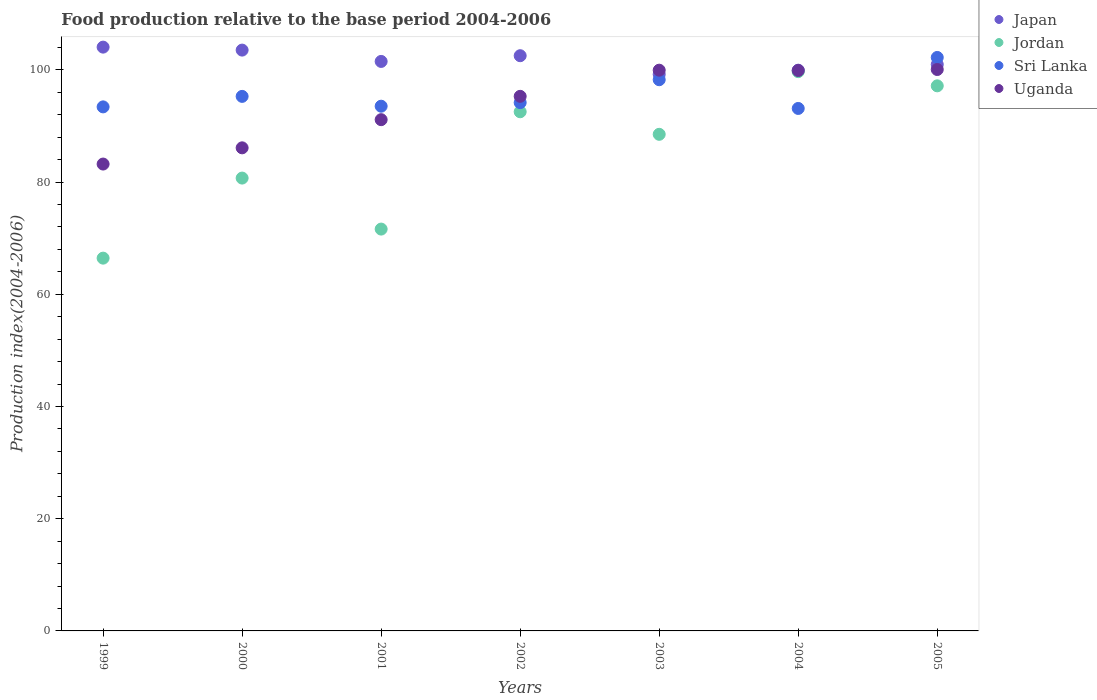How many different coloured dotlines are there?
Your answer should be very brief. 4. What is the food production index in Sri Lanka in 2005?
Your response must be concise. 102.21. Across all years, what is the maximum food production index in Jordan?
Provide a succinct answer. 99.68. Across all years, what is the minimum food production index in Jordan?
Provide a short and direct response. 66.44. What is the total food production index in Uganda in the graph?
Make the answer very short. 655.59. What is the difference between the food production index in Jordan in 1999 and that in 2001?
Your answer should be compact. -5.18. What is the difference between the food production index in Japan in 2002 and the food production index in Uganda in 1999?
Give a very brief answer. 19.31. What is the average food production index in Uganda per year?
Give a very brief answer. 93.66. In the year 2001, what is the difference between the food production index in Jordan and food production index in Uganda?
Give a very brief answer. -19.5. What is the ratio of the food production index in Jordan in 2000 to that in 2004?
Your answer should be very brief. 0.81. Is the food production index in Japan in 2004 less than that in 2005?
Your answer should be compact. Yes. Is the difference between the food production index in Jordan in 1999 and 2005 greater than the difference between the food production index in Uganda in 1999 and 2005?
Ensure brevity in your answer.  No. What is the difference between the highest and the second highest food production index in Sri Lanka?
Provide a short and direct response. 3.97. What is the difference between the highest and the lowest food production index in Sri Lanka?
Make the answer very short. 9.09. Is the sum of the food production index in Japan in 1999 and 2003 greater than the maximum food production index in Sri Lanka across all years?
Offer a terse response. Yes. Does the food production index in Jordan monotonically increase over the years?
Keep it short and to the point. No. Is the food production index in Jordan strictly less than the food production index in Uganda over the years?
Offer a very short reply. Yes. What is the difference between two consecutive major ticks on the Y-axis?
Your response must be concise. 20. Does the graph contain any zero values?
Your response must be concise. No. Does the graph contain grids?
Make the answer very short. No. Where does the legend appear in the graph?
Keep it short and to the point. Top right. How many legend labels are there?
Your response must be concise. 4. How are the legend labels stacked?
Keep it short and to the point. Vertical. What is the title of the graph?
Keep it short and to the point. Food production relative to the base period 2004-2006. What is the label or title of the Y-axis?
Keep it short and to the point. Production index(2004-2006). What is the Production index(2004-2006) in Japan in 1999?
Give a very brief answer. 104.05. What is the Production index(2004-2006) in Jordan in 1999?
Give a very brief answer. 66.44. What is the Production index(2004-2006) of Sri Lanka in 1999?
Your answer should be compact. 93.4. What is the Production index(2004-2006) of Uganda in 1999?
Your answer should be compact. 83.21. What is the Production index(2004-2006) of Japan in 2000?
Offer a very short reply. 103.52. What is the Production index(2004-2006) in Jordan in 2000?
Give a very brief answer. 80.71. What is the Production index(2004-2006) in Sri Lanka in 2000?
Your answer should be very brief. 95.27. What is the Production index(2004-2006) of Uganda in 2000?
Provide a short and direct response. 86.1. What is the Production index(2004-2006) in Japan in 2001?
Ensure brevity in your answer.  101.5. What is the Production index(2004-2006) in Jordan in 2001?
Make the answer very short. 71.62. What is the Production index(2004-2006) of Sri Lanka in 2001?
Give a very brief answer. 93.52. What is the Production index(2004-2006) in Uganda in 2001?
Give a very brief answer. 91.12. What is the Production index(2004-2006) in Japan in 2002?
Offer a very short reply. 102.52. What is the Production index(2004-2006) of Jordan in 2002?
Your answer should be compact. 92.53. What is the Production index(2004-2006) in Sri Lanka in 2002?
Your answer should be very brief. 94.16. What is the Production index(2004-2006) in Uganda in 2002?
Provide a short and direct response. 95.28. What is the Production index(2004-2006) in Japan in 2003?
Give a very brief answer. 99.2. What is the Production index(2004-2006) in Jordan in 2003?
Your answer should be compact. 88.51. What is the Production index(2004-2006) in Sri Lanka in 2003?
Ensure brevity in your answer.  98.24. What is the Production index(2004-2006) of Uganda in 2003?
Ensure brevity in your answer.  99.94. What is the Production index(2004-2006) of Japan in 2004?
Make the answer very short. 99.94. What is the Production index(2004-2006) of Jordan in 2004?
Ensure brevity in your answer.  99.68. What is the Production index(2004-2006) of Sri Lanka in 2004?
Provide a succinct answer. 93.12. What is the Production index(2004-2006) in Uganda in 2004?
Offer a terse response. 99.88. What is the Production index(2004-2006) of Japan in 2005?
Your response must be concise. 100.96. What is the Production index(2004-2006) of Jordan in 2005?
Keep it short and to the point. 97.15. What is the Production index(2004-2006) of Sri Lanka in 2005?
Your answer should be very brief. 102.21. What is the Production index(2004-2006) of Uganda in 2005?
Make the answer very short. 100.06. Across all years, what is the maximum Production index(2004-2006) of Japan?
Ensure brevity in your answer.  104.05. Across all years, what is the maximum Production index(2004-2006) of Jordan?
Offer a terse response. 99.68. Across all years, what is the maximum Production index(2004-2006) in Sri Lanka?
Provide a short and direct response. 102.21. Across all years, what is the maximum Production index(2004-2006) in Uganda?
Your answer should be compact. 100.06. Across all years, what is the minimum Production index(2004-2006) in Japan?
Your answer should be compact. 99.2. Across all years, what is the minimum Production index(2004-2006) in Jordan?
Give a very brief answer. 66.44. Across all years, what is the minimum Production index(2004-2006) in Sri Lanka?
Keep it short and to the point. 93.12. Across all years, what is the minimum Production index(2004-2006) in Uganda?
Your response must be concise. 83.21. What is the total Production index(2004-2006) in Japan in the graph?
Offer a terse response. 711.69. What is the total Production index(2004-2006) of Jordan in the graph?
Make the answer very short. 596.64. What is the total Production index(2004-2006) in Sri Lanka in the graph?
Give a very brief answer. 669.92. What is the total Production index(2004-2006) in Uganda in the graph?
Offer a very short reply. 655.59. What is the difference between the Production index(2004-2006) in Japan in 1999 and that in 2000?
Your answer should be very brief. 0.53. What is the difference between the Production index(2004-2006) in Jordan in 1999 and that in 2000?
Ensure brevity in your answer.  -14.27. What is the difference between the Production index(2004-2006) in Sri Lanka in 1999 and that in 2000?
Ensure brevity in your answer.  -1.87. What is the difference between the Production index(2004-2006) in Uganda in 1999 and that in 2000?
Your answer should be compact. -2.89. What is the difference between the Production index(2004-2006) in Japan in 1999 and that in 2001?
Keep it short and to the point. 2.55. What is the difference between the Production index(2004-2006) in Jordan in 1999 and that in 2001?
Your answer should be very brief. -5.18. What is the difference between the Production index(2004-2006) in Sri Lanka in 1999 and that in 2001?
Offer a terse response. -0.12. What is the difference between the Production index(2004-2006) in Uganda in 1999 and that in 2001?
Ensure brevity in your answer.  -7.91. What is the difference between the Production index(2004-2006) of Japan in 1999 and that in 2002?
Offer a very short reply. 1.53. What is the difference between the Production index(2004-2006) of Jordan in 1999 and that in 2002?
Give a very brief answer. -26.09. What is the difference between the Production index(2004-2006) in Sri Lanka in 1999 and that in 2002?
Provide a succinct answer. -0.76. What is the difference between the Production index(2004-2006) in Uganda in 1999 and that in 2002?
Offer a very short reply. -12.07. What is the difference between the Production index(2004-2006) in Japan in 1999 and that in 2003?
Provide a short and direct response. 4.85. What is the difference between the Production index(2004-2006) of Jordan in 1999 and that in 2003?
Provide a succinct answer. -22.07. What is the difference between the Production index(2004-2006) in Sri Lanka in 1999 and that in 2003?
Give a very brief answer. -4.84. What is the difference between the Production index(2004-2006) of Uganda in 1999 and that in 2003?
Keep it short and to the point. -16.73. What is the difference between the Production index(2004-2006) in Japan in 1999 and that in 2004?
Your answer should be very brief. 4.11. What is the difference between the Production index(2004-2006) of Jordan in 1999 and that in 2004?
Provide a succinct answer. -33.24. What is the difference between the Production index(2004-2006) in Sri Lanka in 1999 and that in 2004?
Provide a short and direct response. 0.28. What is the difference between the Production index(2004-2006) in Uganda in 1999 and that in 2004?
Offer a terse response. -16.67. What is the difference between the Production index(2004-2006) in Japan in 1999 and that in 2005?
Ensure brevity in your answer.  3.09. What is the difference between the Production index(2004-2006) of Jordan in 1999 and that in 2005?
Offer a terse response. -30.71. What is the difference between the Production index(2004-2006) in Sri Lanka in 1999 and that in 2005?
Your answer should be very brief. -8.81. What is the difference between the Production index(2004-2006) of Uganda in 1999 and that in 2005?
Offer a terse response. -16.85. What is the difference between the Production index(2004-2006) in Japan in 2000 and that in 2001?
Provide a short and direct response. 2.02. What is the difference between the Production index(2004-2006) of Jordan in 2000 and that in 2001?
Your answer should be very brief. 9.09. What is the difference between the Production index(2004-2006) of Uganda in 2000 and that in 2001?
Provide a succinct answer. -5.02. What is the difference between the Production index(2004-2006) of Jordan in 2000 and that in 2002?
Your answer should be very brief. -11.82. What is the difference between the Production index(2004-2006) of Sri Lanka in 2000 and that in 2002?
Keep it short and to the point. 1.11. What is the difference between the Production index(2004-2006) in Uganda in 2000 and that in 2002?
Provide a short and direct response. -9.18. What is the difference between the Production index(2004-2006) of Japan in 2000 and that in 2003?
Keep it short and to the point. 4.32. What is the difference between the Production index(2004-2006) of Sri Lanka in 2000 and that in 2003?
Keep it short and to the point. -2.97. What is the difference between the Production index(2004-2006) of Uganda in 2000 and that in 2003?
Keep it short and to the point. -13.84. What is the difference between the Production index(2004-2006) of Japan in 2000 and that in 2004?
Provide a succinct answer. 3.58. What is the difference between the Production index(2004-2006) of Jordan in 2000 and that in 2004?
Offer a terse response. -18.97. What is the difference between the Production index(2004-2006) of Sri Lanka in 2000 and that in 2004?
Ensure brevity in your answer.  2.15. What is the difference between the Production index(2004-2006) in Uganda in 2000 and that in 2004?
Ensure brevity in your answer.  -13.78. What is the difference between the Production index(2004-2006) in Japan in 2000 and that in 2005?
Give a very brief answer. 2.56. What is the difference between the Production index(2004-2006) of Jordan in 2000 and that in 2005?
Provide a short and direct response. -16.44. What is the difference between the Production index(2004-2006) in Sri Lanka in 2000 and that in 2005?
Offer a very short reply. -6.94. What is the difference between the Production index(2004-2006) in Uganda in 2000 and that in 2005?
Offer a very short reply. -13.96. What is the difference between the Production index(2004-2006) of Japan in 2001 and that in 2002?
Your response must be concise. -1.02. What is the difference between the Production index(2004-2006) in Jordan in 2001 and that in 2002?
Your response must be concise. -20.91. What is the difference between the Production index(2004-2006) in Sri Lanka in 2001 and that in 2002?
Your response must be concise. -0.64. What is the difference between the Production index(2004-2006) in Uganda in 2001 and that in 2002?
Offer a terse response. -4.16. What is the difference between the Production index(2004-2006) of Jordan in 2001 and that in 2003?
Offer a very short reply. -16.89. What is the difference between the Production index(2004-2006) of Sri Lanka in 2001 and that in 2003?
Your answer should be compact. -4.72. What is the difference between the Production index(2004-2006) of Uganda in 2001 and that in 2003?
Give a very brief answer. -8.82. What is the difference between the Production index(2004-2006) of Japan in 2001 and that in 2004?
Keep it short and to the point. 1.56. What is the difference between the Production index(2004-2006) in Jordan in 2001 and that in 2004?
Give a very brief answer. -28.06. What is the difference between the Production index(2004-2006) of Uganda in 2001 and that in 2004?
Keep it short and to the point. -8.76. What is the difference between the Production index(2004-2006) in Japan in 2001 and that in 2005?
Provide a short and direct response. 0.54. What is the difference between the Production index(2004-2006) of Jordan in 2001 and that in 2005?
Offer a very short reply. -25.53. What is the difference between the Production index(2004-2006) of Sri Lanka in 2001 and that in 2005?
Your response must be concise. -8.69. What is the difference between the Production index(2004-2006) of Uganda in 2001 and that in 2005?
Provide a succinct answer. -8.94. What is the difference between the Production index(2004-2006) in Japan in 2002 and that in 2003?
Provide a succinct answer. 3.32. What is the difference between the Production index(2004-2006) in Jordan in 2002 and that in 2003?
Provide a succinct answer. 4.02. What is the difference between the Production index(2004-2006) of Sri Lanka in 2002 and that in 2003?
Provide a short and direct response. -4.08. What is the difference between the Production index(2004-2006) in Uganda in 2002 and that in 2003?
Keep it short and to the point. -4.66. What is the difference between the Production index(2004-2006) in Japan in 2002 and that in 2004?
Keep it short and to the point. 2.58. What is the difference between the Production index(2004-2006) of Jordan in 2002 and that in 2004?
Ensure brevity in your answer.  -7.15. What is the difference between the Production index(2004-2006) in Uganda in 2002 and that in 2004?
Provide a succinct answer. -4.6. What is the difference between the Production index(2004-2006) of Japan in 2002 and that in 2005?
Make the answer very short. 1.56. What is the difference between the Production index(2004-2006) in Jordan in 2002 and that in 2005?
Provide a succinct answer. -4.62. What is the difference between the Production index(2004-2006) in Sri Lanka in 2002 and that in 2005?
Offer a terse response. -8.05. What is the difference between the Production index(2004-2006) of Uganda in 2002 and that in 2005?
Offer a terse response. -4.78. What is the difference between the Production index(2004-2006) of Japan in 2003 and that in 2004?
Offer a very short reply. -0.74. What is the difference between the Production index(2004-2006) in Jordan in 2003 and that in 2004?
Give a very brief answer. -11.17. What is the difference between the Production index(2004-2006) in Sri Lanka in 2003 and that in 2004?
Offer a terse response. 5.12. What is the difference between the Production index(2004-2006) in Japan in 2003 and that in 2005?
Ensure brevity in your answer.  -1.76. What is the difference between the Production index(2004-2006) in Jordan in 2003 and that in 2005?
Provide a short and direct response. -8.64. What is the difference between the Production index(2004-2006) in Sri Lanka in 2003 and that in 2005?
Ensure brevity in your answer.  -3.97. What is the difference between the Production index(2004-2006) of Uganda in 2003 and that in 2005?
Provide a short and direct response. -0.12. What is the difference between the Production index(2004-2006) of Japan in 2004 and that in 2005?
Ensure brevity in your answer.  -1.02. What is the difference between the Production index(2004-2006) in Jordan in 2004 and that in 2005?
Provide a short and direct response. 2.53. What is the difference between the Production index(2004-2006) of Sri Lanka in 2004 and that in 2005?
Provide a short and direct response. -9.09. What is the difference between the Production index(2004-2006) in Uganda in 2004 and that in 2005?
Offer a terse response. -0.18. What is the difference between the Production index(2004-2006) in Japan in 1999 and the Production index(2004-2006) in Jordan in 2000?
Make the answer very short. 23.34. What is the difference between the Production index(2004-2006) of Japan in 1999 and the Production index(2004-2006) of Sri Lanka in 2000?
Your answer should be compact. 8.78. What is the difference between the Production index(2004-2006) in Japan in 1999 and the Production index(2004-2006) in Uganda in 2000?
Keep it short and to the point. 17.95. What is the difference between the Production index(2004-2006) of Jordan in 1999 and the Production index(2004-2006) of Sri Lanka in 2000?
Give a very brief answer. -28.83. What is the difference between the Production index(2004-2006) in Jordan in 1999 and the Production index(2004-2006) in Uganda in 2000?
Provide a short and direct response. -19.66. What is the difference between the Production index(2004-2006) in Japan in 1999 and the Production index(2004-2006) in Jordan in 2001?
Ensure brevity in your answer.  32.43. What is the difference between the Production index(2004-2006) of Japan in 1999 and the Production index(2004-2006) of Sri Lanka in 2001?
Make the answer very short. 10.53. What is the difference between the Production index(2004-2006) in Japan in 1999 and the Production index(2004-2006) in Uganda in 2001?
Provide a succinct answer. 12.93. What is the difference between the Production index(2004-2006) in Jordan in 1999 and the Production index(2004-2006) in Sri Lanka in 2001?
Give a very brief answer. -27.08. What is the difference between the Production index(2004-2006) in Jordan in 1999 and the Production index(2004-2006) in Uganda in 2001?
Provide a succinct answer. -24.68. What is the difference between the Production index(2004-2006) of Sri Lanka in 1999 and the Production index(2004-2006) of Uganda in 2001?
Your answer should be very brief. 2.28. What is the difference between the Production index(2004-2006) in Japan in 1999 and the Production index(2004-2006) in Jordan in 2002?
Your response must be concise. 11.52. What is the difference between the Production index(2004-2006) in Japan in 1999 and the Production index(2004-2006) in Sri Lanka in 2002?
Make the answer very short. 9.89. What is the difference between the Production index(2004-2006) of Japan in 1999 and the Production index(2004-2006) of Uganda in 2002?
Keep it short and to the point. 8.77. What is the difference between the Production index(2004-2006) of Jordan in 1999 and the Production index(2004-2006) of Sri Lanka in 2002?
Your answer should be very brief. -27.72. What is the difference between the Production index(2004-2006) in Jordan in 1999 and the Production index(2004-2006) in Uganda in 2002?
Keep it short and to the point. -28.84. What is the difference between the Production index(2004-2006) of Sri Lanka in 1999 and the Production index(2004-2006) of Uganda in 2002?
Keep it short and to the point. -1.88. What is the difference between the Production index(2004-2006) of Japan in 1999 and the Production index(2004-2006) of Jordan in 2003?
Provide a succinct answer. 15.54. What is the difference between the Production index(2004-2006) in Japan in 1999 and the Production index(2004-2006) in Sri Lanka in 2003?
Make the answer very short. 5.81. What is the difference between the Production index(2004-2006) in Japan in 1999 and the Production index(2004-2006) in Uganda in 2003?
Offer a very short reply. 4.11. What is the difference between the Production index(2004-2006) of Jordan in 1999 and the Production index(2004-2006) of Sri Lanka in 2003?
Your response must be concise. -31.8. What is the difference between the Production index(2004-2006) in Jordan in 1999 and the Production index(2004-2006) in Uganda in 2003?
Make the answer very short. -33.5. What is the difference between the Production index(2004-2006) of Sri Lanka in 1999 and the Production index(2004-2006) of Uganda in 2003?
Offer a terse response. -6.54. What is the difference between the Production index(2004-2006) of Japan in 1999 and the Production index(2004-2006) of Jordan in 2004?
Make the answer very short. 4.37. What is the difference between the Production index(2004-2006) in Japan in 1999 and the Production index(2004-2006) in Sri Lanka in 2004?
Make the answer very short. 10.93. What is the difference between the Production index(2004-2006) in Japan in 1999 and the Production index(2004-2006) in Uganda in 2004?
Your response must be concise. 4.17. What is the difference between the Production index(2004-2006) of Jordan in 1999 and the Production index(2004-2006) of Sri Lanka in 2004?
Provide a short and direct response. -26.68. What is the difference between the Production index(2004-2006) in Jordan in 1999 and the Production index(2004-2006) in Uganda in 2004?
Make the answer very short. -33.44. What is the difference between the Production index(2004-2006) in Sri Lanka in 1999 and the Production index(2004-2006) in Uganda in 2004?
Provide a short and direct response. -6.48. What is the difference between the Production index(2004-2006) of Japan in 1999 and the Production index(2004-2006) of Sri Lanka in 2005?
Your answer should be compact. 1.84. What is the difference between the Production index(2004-2006) of Japan in 1999 and the Production index(2004-2006) of Uganda in 2005?
Make the answer very short. 3.99. What is the difference between the Production index(2004-2006) in Jordan in 1999 and the Production index(2004-2006) in Sri Lanka in 2005?
Ensure brevity in your answer.  -35.77. What is the difference between the Production index(2004-2006) in Jordan in 1999 and the Production index(2004-2006) in Uganda in 2005?
Make the answer very short. -33.62. What is the difference between the Production index(2004-2006) of Sri Lanka in 1999 and the Production index(2004-2006) of Uganda in 2005?
Offer a terse response. -6.66. What is the difference between the Production index(2004-2006) in Japan in 2000 and the Production index(2004-2006) in Jordan in 2001?
Your answer should be very brief. 31.9. What is the difference between the Production index(2004-2006) of Japan in 2000 and the Production index(2004-2006) of Sri Lanka in 2001?
Give a very brief answer. 10. What is the difference between the Production index(2004-2006) in Japan in 2000 and the Production index(2004-2006) in Uganda in 2001?
Provide a short and direct response. 12.4. What is the difference between the Production index(2004-2006) of Jordan in 2000 and the Production index(2004-2006) of Sri Lanka in 2001?
Keep it short and to the point. -12.81. What is the difference between the Production index(2004-2006) of Jordan in 2000 and the Production index(2004-2006) of Uganda in 2001?
Provide a short and direct response. -10.41. What is the difference between the Production index(2004-2006) of Sri Lanka in 2000 and the Production index(2004-2006) of Uganda in 2001?
Give a very brief answer. 4.15. What is the difference between the Production index(2004-2006) in Japan in 2000 and the Production index(2004-2006) in Jordan in 2002?
Give a very brief answer. 10.99. What is the difference between the Production index(2004-2006) in Japan in 2000 and the Production index(2004-2006) in Sri Lanka in 2002?
Offer a very short reply. 9.36. What is the difference between the Production index(2004-2006) in Japan in 2000 and the Production index(2004-2006) in Uganda in 2002?
Your response must be concise. 8.24. What is the difference between the Production index(2004-2006) in Jordan in 2000 and the Production index(2004-2006) in Sri Lanka in 2002?
Give a very brief answer. -13.45. What is the difference between the Production index(2004-2006) of Jordan in 2000 and the Production index(2004-2006) of Uganda in 2002?
Make the answer very short. -14.57. What is the difference between the Production index(2004-2006) of Sri Lanka in 2000 and the Production index(2004-2006) of Uganda in 2002?
Offer a terse response. -0.01. What is the difference between the Production index(2004-2006) of Japan in 2000 and the Production index(2004-2006) of Jordan in 2003?
Offer a terse response. 15.01. What is the difference between the Production index(2004-2006) in Japan in 2000 and the Production index(2004-2006) in Sri Lanka in 2003?
Keep it short and to the point. 5.28. What is the difference between the Production index(2004-2006) of Japan in 2000 and the Production index(2004-2006) of Uganda in 2003?
Give a very brief answer. 3.58. What is the difference between the Production index(2004-2006) of Jordan in 2000 and the Production index(2004-2006) of Sri Lanka in 2003?
Offer a very short reply. -17.53. What is the difference between the Production index(2004-2006) of Jordan in 2000 and the Production index(2004-2006) of Uganda in 2003?
Give a very brief answer. -19.23. What is the difference between the Production index(2004-2006) in Sri Lanka in 2000 and the Production index(2004-2006) in Uganda in 2003?
Your answer should be compact. -4.67. What is the difference between the Production index(2004-2006) of Japan in 2000 and the Production index(2004-2006) of Jordan in 2004?
Make the answer very short. 3.84. What is the difference between the Production index(2004-2006) of Japan in 2000 and the Production index(2004-2006) of Uganda in 2004?
Provide a short and direct response. 3.64. What is the difference between the Production index(2004-2006) of Jordan in 2000 and the Production index(2004-2006) of Sri Lanka in 2004?
Offer a very short reply. -12.41. What is the difference between the Production index(2004-2006) in Jordan in 2000 and the Production index(2004-2006) in Uganda in 2004?
Provide a succinct answer. -19.17. What is the difference between the Production index(2004-2006) in Sri Lanka in 2000 and the Production index(2004-2006) in Uganda in 2004?
Give a very brief answer. -4.61. What is the difference between the Production index(2004-2006) in Japan in 2000 and the Production index(2004-2006) in Jordan in 2005?
Offer a very short reply. 6.37. What is the difference between the Production index(2004-2006) in Japan in 2000 and the Production index(2004-2006) in Sri Lanka in 2005?
Your response must be concise. 1.31. What is the difference between the Production index(2004-2006) in Japan in 2000 and the Production index(2004-2006) in Uganda in 2005?
Ensure brevity in your answer.  3.46. What is the difference between the Production index(2004-2006) in Jordan in 2000 and the Production index(2004-2006) in Sri Lanka in 2005?
Your answer should be compact. -21.5. What is the difference between the Production index(2004-2006) of Jordan in 2000 and the Production index(2004-2006) of Uganda in 2005?
Provide a succinct answer. -19.35. What is the difference between the Production index(2004-2006) of Sri Lanka in 2000 and the Production index(2004-2006) of Uganda in 2005?
Make the answer very short. -4.79. What is the difference between the Production index(2004-2006) of Japan in 2001 and the Production index(2004-2006) of Jordan in 2002?
Offer a very short reply. 8.97. What is the difference between the Production index(2004-2006) in Japan in 2001 and the Production index(2004-2006) in Sri Lanka in 2002?
Provide a short and direct response. 7.34. What is the difference between the Production index(2004-2006) in Japan in 2001 and the Production index(2004-2006) in Uganda in 2002?
Your answer should be compact. 6.22. What is the difference between the Production index(2004-2006) in Jordan in 2001 and the Production index(2004-2006) in Sri Lanka in 2002?
Your response must be concise. -22.54. What is the difference between the Production index(2004-2006) in Jordan in 2001 and the Production index(2004-2006) in Uganda in 2002?
Offer a very short reply. -23.66. What is the difference between the Production index(2004-2006) in Sri Lanka in 2001 and the Production index(2004-2006) in Uganda in 2002?
Make the answer very short. -1.76. What is the difference between the Production index(2004-2006) in Japan in 2001 and the Production index(2004-2006) in Jordan in 2003?
Ensure brevity in your answer.  12.99. What is the difference between the Production index(2004-2006) in Japan in 2001 and the Production index(2004-2006) in Sri Lanka in 2003?
Offer a very short reply. 3.26. What is the difference between the Production index(2004-2006) in Japan in 2001 and the Production index(2004-2006) in Uganda in 2003?
Ensure brevity in your answer.  1.56. What is the difference between the Production index(2004-2006) in Jordan in 2001 and the Production index(2004-2006) in Sri Lanka in 2003?
Offer a terse response. -26.62. What is the difference between the Production index(2004-2006) in Jordan in 2001 and the Production index(2004-2006) in Uganda in 2003?
Your answer should be compact. -28.32. What is the difference between the Production index(2004-2006) of Sri Lanka in 2001 and the Production index(2004-2006) of Uganda in 2003?
Provide a short and direct response. -6.42. What is the difference between the Production index(2004-2006) in Japan in 2001 and the Production index(2004-2006) in Jordan in 2004?
Make the answer very short. 1.82. What is the difference between the Production index(2004-2006) of Japan in 2001 and the Production index(2004-2006) of Sri Lanka in 2004?
Your response must be concise. 8.38. What is the difference between the Production index(2004-2006) in Japan in 2001 and the Production index(2004-2006) in Uganda in 2004?
Provide a succinct answer. 1.62. What is the difference between the Production index(2004-2006) of Jordan in 2001 and the Production index(2004-2006) of Sri Lanka in 2004?
Your answer should be very brief. -21.5. What is the difference between the Production index(2004-2006) of Jordan in 2001 and the Production index(2004-2006) of Uganda in 2004?
Ensure brevity in your answer.  -28.26. What is the difference between the Production index(2004-2006) in Sri Lanka in 2001 and the Production index(2004-2006) in Uganda in 2004?
Your response must be concise. -6.36. What is the difference between the Production index(2004-2006) of Japan in 2001 and the Production index(2004-2006) of Jordan in 2005?
Provide a succinct answer. 4.35. What is the difference between the Production index(2004-2006) of Japan in 2001 and the Production index(2004-2006) of Sri Lanka in 2005?
Give a very brief answer. -0.71. What is the difference between the Production index(2004-2006) of Japan in 2001 and the Production index(2004-2006) of Uganda in 2005?
Offer a terse response. 1.44. What is the difference between the Production index(2004-2006) of Jordan in 2001 and the Production index(2004-2006) of Sri Lanka in 2005?
Offer a terse response. -30.59. What is the difference between the Production index(2004-2006) of Jordan in 2001 and the Production index(2004-2006) of Uganda in 2005?
Your answer should be very brief. -28.44. What is the difference between the Production index(2004-2006) in Sri Lanka in 2001 and the Production index(2004-2006) in Uganda in 2005?
Make the answer very short. -6.54. What is the difference between the Production index(2004-2006) of Japan in 2002 and the Production index(2004-2006) of Jordan in 2003?
Your answer should be very brief. 14.01. What is the difference between the Production index(2004-2006) in Japan in 2002 and the Production index(2004-2006) in Sri Lanka in 2003?
Provide a short and direct response. 4.28. What is the difference between the Production index(2004-2006) in Japan in 2002 and the Production index(2004-2006) in Uganda in 2003?
Keep it short and to the point. 2.58. What is the difference between the Production index(2004-2006) in Jordan in 2002 and the Production index(2004-2006) in Sri Lanka in 2003?
Make the answer very short. -5.71. What is the difference between the Production index(2004-2006) of Jordan in 2002 and the Production index(2004-2006) of Uganda in 2003?
Make the answer very short. -7.41. What is the difference between the Production index(2004-2006) of Sri Lanka in 2002 and the Production index(2004-2006) of Uganda in 2003?
Keep it short and to the point. -5.78. What is the difference between the Production index(2004-2006) in Japan in 2002 and the Production index(2004-2006) in Jordan in 2004?
Ensure brevity in your answer.  2.84. What is the difference between the Production index(2004-2006) of Japan in 2002 and the Production index(2004-2006) of Uganda in 2004?
Your response must be concise. 2.64. What is the difference between the Production index(2004-2006) in Jordan in 2002 and the Production index(2004-2006) in Sri Lanka in 2004?
Your answer should be very brief. -0.59. What is the difference between the Production index(2004-2006) in Jordan in 2002 and the Production index(2004-2006) in Uganda in 2004?
Ensure brevity in your answer.  -7.35. What is the difference between the Production index(2004-2006) of Sri Lanka in 2002 and the Production index(2004-2006) of Uganda in 2004?
Provide a succinct answer. -5.72. What is the difference between the Production index(2004-2006) of Japan in 2002 and the Production index(2004-2006) of Jordan in 2005?
Make the answer very short. 5.37. What is the difference between the Production index(2004-2006) of Japan in 2002 and the Production index(2004-2006) of Sri Lanka in 2005?
Provide a short and direct response. 0.31. What is the difference between the Production index(2004-2006) of Japan in 2002 and the Production index(2004-2006) of Uganda in 2005?
Your answer should be very brief. 2.46. What is the difference between the Production index(2004-2006) of Jordan in 2002 and the Production index(2004-2006) of Sri Lanka in 2005?
Keep it short and to the point. -9.68. What is the difference between the Production index(2004-2006) of Jordan in 2002 and the Production index(2004-2006) of Uganda in 2005?
Keep it short and to the point. -7.53. What is the difference between the Production index(2004-2006) in Japan in 2003 and the Production index(2004-2006) in Jordan in 2004?
Your answer should be compact. -0.48. What is the difference between the Production index(2004-2006) of Japan in 2003 and the Production index(2004-2006) of Sri Lanka in 2004?
Ensure brevity in your answer.  6.08. What is the difference between the Production index(2004-2006) of Japan in 2003 and the Production index(2004-2006) of Uganda in 2004?
Your answer should be very brief. -0.68. What is the difference between the Production index(2004-2006) in Jordan in 2003 and the Production index(2004-2006) in Sri Lanka in 2004?
Offer a very short reply. -4.61. What is the difference between the Production index(2004-2006) of Jordan in 2003 and the Production index(2004-2006) of Uganda in 2004?
Offer a very short reply. -11.37. What is the difference between the Production index(2004-2006) in Sri Lanka in 2003 and the Production index(2004-2006) in Uganda in 2004?
Keep it short and to the point. -1.64. What is the difference between the Production index(2004-2006) in Japan in 2003 and the Production index(2004-2006) in Jordan in 2005?
Provide a short and direct response. 2.05. What is the difference between the Production index(2004-2006) of Japan in 2003 and the Production index(2004-2006) of Sri Lanka in 2005?
Your response must be concise. -3.01. What is the difference between the Production index(2004-2006) of Japan in 2003 and the Production index(2004-2006) of Uganda in 2005?
Provide a succinct answer. -0.86. What is the difference between the Production index(2004-2006) in Jordan in 2003 and the Production index(2004-2006) in Sri Lanka in 2005?
Ensure brevity in your answer.  -13.7. What is the difference between the Production index(2004-2006) in Jordan in 2003 and the Production index(2004-2006) in Uganda in 2005?
Ensure brevity in your answer.  -11.55. What is the difference between the Production index(2004-2006) of Sri Lanka in 2003 and the Production index(2004-2006) of Uganda in 2005?
Give a very brief answer. -1.82. What is the difference between the Production index(2004-2006) in Japan in 2004 and the Production index(2004-2006) in Jordan in 2005?
Provide a short and direct response. 2.79. What is the difference between the Production index(2004-2006) in Japan in 2004 and the Production index(2004-2006) in Sri Lanka in 2005?
Your answer should be compact. -2.27. What is the difference between the Production index(2004-2006) in Japan in 2004 and the Production index(2004-2006) in Uganda in 2005?
Offer a very short reply. -0.12. What is the difference between the Production index(2004-2006) of Jordan in 2004 and the Production index(2004-2006) of Sri Lanka in 2005?
Make the answer very short. -2.53. What is the difference between the Production index(2004-2006) of Jordan in 2004 and the Production index(2004-2006) of Uganda in 2005?
Ensure brevity in your answer.  -0.38. What is the difference between the Production index(2004-2006) in Sri Lanka in 2004 and the Production index(2004-2006) in Uganda in 2005?
Give a very brief answer. -6.94. What is the average Production index(2004-2006) in Japan per year?
Provide a succinct answer. 101.67. What is the average Production index(2004-2006) in Jordan per year?
Offer a very short reply. 85.23. What is the average Production index(2004-2006) in Sri Lanka per year?
Offer a terse response. 95.7. What is the average Production index(2004-2006) of Uganda per year?
Your response must be concise. 93.66. In the year 1999, what is the difference between the Production index(2004-2006) of Japan and Production index(2004-2006) of Jordan?
Your response must be concise. 37.61. In the year 1999, what is the difference between the Production index(2004-2006) in Japan and Production index(2004-2006) in Sri Lanka?
Keep it short and to the point. 10.65. In the year 1999, what is the difference between the Production index(2004-2006) in Japan and Production index(2004-2006) in Uganda?
Keep it short and to the point. 20.84. In the year 1999, what is the difference between the Production index(2004-2006) in Jordan and Production index(2004-2006) in Sri Lanka?
Give a very brief answer. -26.96. In the year 1999, what is the difference between the Production index(2004-2006) in Jordan and Production index(2004-2006) in Uganda?
Make the answer very short. -16.77. In the year 1999, what is the difference between the Production index(2004-2006) in Sri Lanka and Production index(2004-2006) in Uganda?
Keep it short and to the point. 10.19. In the year 2000, what is the difference between the Production index(2004-2006) in Japan and Production index(2004-2006) in Jordan?
Provide a short and direct response. 22.81. In the year 2000, what is the difference between the Production index(2004-2006) of Japan and Production index(2004-2006) of Sri Lanka?
Your answer should be very brief. 8.25. In the year 2000, what is the difference between the Production index(2004-2006) in Japan and Production index(2004-2006) in Uganda?
Keep it short and to the point. 17.42. In the year 2000, what is the difference between the Production index(2004-2006) of Jordan and Production index(2004-2006) of Sri Lanka?
Provide a succinct answer. -14.56. In the year 2000, what is the difference between the Production index(2004-2006) of Jordan and Production index(2004-2006) of Uganda?
Keep it short and to the point. -5.39. In the year 2000, what is the difference between the Production index(2004-2006) in Sri Lanka and Production index(2004-2006) in Uganda?
Offer a terse response. 9.17. In the year 2001, what is the difference between the Production index(2004-2006) in Japan and Production index(2004-2006) in Jordan?
Make the answer very short. 29.88. In the year 2001, what is the difference between the Production index(2004-2006) in Japan and Production index(2004-2006) in Sri Lanka?
Provide a succinct answer. 7.98. In the year 2001, what is the difference between the Production index(2004-2006) in Japan and Production index(2004-2006) in Uganda?
Your answer should be very brief. 10.38. In the year 2001, what is the difference between the Production index(2004-2006) in Jordan and Production index(2004-2006) in Sri Lanka?
Give a very brief answer. -21.9. In the year 2001, what is the difference between the Production index(2004-2006) in Jordan and Production index(2004-2006) in Uganda?
Offer a very short reply. -19.5. In the year 2002, what is the difference between the Production index(2004-2006) in Japan and Production index(2004-2006) in Jordan?
Your answer should be very brief. 9.99. In the year 2002, what is the difference between the Production index(2004-2006) of Japan and Production index(2004-2006) of Sri Lanka?
Offer a very short reply. 8.36. In the year 2002, what is the difference between the Production index(2004-2006) in Japan and Production index(2004-2006) in Uganda?
Keep it short and to the point. 7.24. In the year 2002, what is the difference between the Production index(2004-2006) of Jordan and Production index(2004-2006) of Sri Lanka?
Offer a very short reply. -1.63. In the year 2002, what is the difference between the Production index(2004-2006) in Jordan and Production index(2004-2006) in Uganda?
Provide a succinct answer. -2.75. In the year 2002, what is the difference between the Production index(2004-2006) in Sri Lanka and Production index(2004-2006) in Uganda?
Keep it short and to the point. -1.12. In the year 2003, what is the difference between the Production index(2004-2006) of Japan and Production index(2004-2006) of Jordan?
Give a very brief answer. 10.69. In the year 2003, what is the difference between the Production index(2004-2006) of Japan and Production index(2004-2006) of Sri Lanka?
Give a very brief answer. 0.96. In the year 2003, what is the difference between the Production index(2004-2006) in Japan and Production index(2004-2006) in Uganda?
Provide a short and direct response. -0.74. In the year 2003, what is the difference between the Production index(2004-2006) in Jordan and Production index(2004-2006) in Sri Lanka?
Give a very brief answer. -9.73. In the year 2003, what is the difference between the Production index(2004-2006) of Jordan and Production index(2004-2006) of Uganda?
Provide a short and direct response. -11.43. In the year 2003, what is the difference between the Production index(2004-2006) in Sri Lanka and Production index(2004-2006) in Uganda?
Keep it short and to the point. -1.7. In the year 2004, what is the difference between the Production index(2004-2006) in Japan and Production index(2004-2006) in Jordan?
Make the answer very short. 0.26. In the year 2004, what is the difference between the Production index(2004-2006) of Japan and Production index(2004-2006) of Sri Lanka?
Offer a terse response. 6.82. In the year 2004, what is the difference between the Production index(2004-2006) of Jordan and Production index(2004-2006) of Sri Lanka?
Ensure brevity in your answer.  6.56. In the year 2004, what is the difference between the Production index(2004-2006) in Sri Lanka and Production index(2004-2006) in Uganda?
Offer a very short reply. -6.76. In the year 2005, what is the difference between the Production index(2004-2006) in Japan and Production index(2004-2006) in Jordan?
Ensure brevity in your answer.  3.81. In the year 2005, what is the difference between the Production index(2004-2006) of Japan and Production index(2004-2006) of Sri Lanka?
Your response must be concise. -1.25. In the year 2005, what is the difference between the Production index(2004-2006) in Japan and Production index(2004-2006) in Uganda?
Your answer should be compact. 0.9. In the year 2005, what is the difference between the Production index(2004-2006) in Jordan and Production index(2004-2006) in Sri Lanka?
Ensure brevity in your answer.  -5.06. In the year 2005, what is the difference between the Production index(2004-2006) of Jordan and Production index(2004-2006) of Uganda?
Your answer should be compact. -2.91. In the year 2005, what is the difference between the Production index(2004-2006) of Sri Lanka and Production index(2004-2006) of Uganda?
Ensure brevity in your answer.  2.15. What is the ratio of the Production index(2004-2006) in Japan in 1999 to that in 2000?
Your answer should be compact. 1.01. What is the ratio of the Production index(2004-2006) of Jordan in 1999 to that in 2000?
Make the answer very short. 0.82. What is the ratio of the Production index(2004-2006) in Sri Lanka in 1999 to that in 2000?
Provide a succinct answer. 0.98. What is the ratio of the Production index(2004-2006) of Uganda in 1999 to that in 2000?
Your answer should be compact. 0.97. What is the ratio of the Production index(2004-2006) in Japan in 1999 to that in 2001?
Your response must be concise. 1.03. What is the ratio of the Production index(2004-2006) in Jordan in 1999 to that in 2001?
Make the answer very short. 0.93. What is the ratio of the Production index(2004-2006) in Sri Lanka in 1999 to that in 2001?
Ensure brevity in your answer.  1. What is the ratio of the Production index(2004-2006) in Uganda in 1999 to that in 2001?
Provide a short and direct response. 0.91. What is the ratio of the Production index(2004-2006) in Japan in 1999 to that in 2002?
Your answer should be compact. 1.01. What is the ratio of the Production index(2004-2006) in Jordan in 1999 to that in 2002?
Offer a very short reply. 0.72. What is the ratio of the Production index(2004-2006) of Uganda in 1999 to that in 2002?
Your answer should be compact. 0.87. What is the ratio of the Production index(2004-2006) in Japan in 1999 to that in 2003?
Give a very brief answer. 1.05. What is the ratio of the Production index(2004-2006) of Jordan in 1999 to that in 2003?
Your answer should be compact. 0.75. What is the ratio of the Production index(2004-2006) of Sri Lanka in 1999 to that in 2003?
Keep it short and to the point. 0.95. What is the ratio of the Production index(2004-2006) in Uganda in 1999 to that in 2003?
Offer a terse response. 0.83. What is the ratio of the Production index(2004-2006) in Japan in 1999 to that in 2004?
Ensure brevity in your answer.  1.04. What is the ratio of the Production index(2004-2006) of Jordan in 1999 to that in 2004?
Offer a terse response. 0.67. What is the ratio of the Production index(2004-2006) in Sri Lanka in 1999 to that in 2004?
Give a very brief answer. 1. What is the ratio of the Production index(2004-2006) in Uganda in 1999 to that in 2004?
Ensure brevity in your answer.  0.83. What is the ratio of the Production index(2004-2006) of Japan in 1999 to that in 2005?
Offer a terse response. 1.03. What is the ratio of the Production index(2004-2006) of Jordan in 1999 to that in 2005?
Your answer should be very brief. 0.68. What is the ratio of the Production index(2004-2006) in Sri Lanka in 1999 to that in 2005?
Your answer should be compact. 0.91. What is the ratio of the Production index(2004-2006) of Uganda in 1999 to that in 2005?
Offer a terse response. 0.83. What is the ratio of the Production index(2004-2006) of Japan in 2000 to that in 2001?
Your response must be concise. 1.02. What is the ratio of the Production index(2004-2006) of Jordan in 2000 to that in 2001?
Give a very brief answer. 1.13. What is the ratio of the Production index(2004-2006) in Sri Lanka in 2000 to that in 2001?
Offer a very short reply. 1.02. What is the ratio of the Production index(2004-2006) in Uganda in 2000 to that in 2001?
Provide a succinct answer. 0.94. What is the ratio of the Production index(2004-2006) in Japan in 2000 to that in 2002?
Provide a succinct answer. 1.01. What is the ratio of the Production index(2004-2006) in Jordan in 2000 to that in 2002?
Offer a terse response. 0.87. What is the ratio of the Production index(2004-2006) in Sri Lanka in 2000 to that in 2002?
Your answer should be very brief. 1.01. What is the ratio of the Production index(2004-2006) of Uganda in 2000 to that in 2002?
Keep it short and to the point. 0.9. What is the ratio of the Production index(2004-2006) in Japan in 2000 to that in 2003?
Give a very brief answer. 1.04. What is the ratio of the Production index(2004-2006) in Jordan in 2000 to that in 2003?
Your answer should be compact. 0.91. What is the ratio of the Production index(2004-2006) in Sri Lanka in 2000 to that in 2003?
Offer a terse response. 0.97. What is the ratio of the Production index(2004-2006) of Uganda in 2000 to that in 2003?
Provide a succinct answer. 0.86. What is the ratio of the Production index(2004-2006) in Japan in 2000 to that in 2004?
Give a very brief answer. 1.04. What is the ratio of the Production index(2004-2006) in Jordan in 2000 to that in 2004?
Give a very brief answer. 0.81. What is the ratio of the Production index(2004-2006) of Sri Lanka in 2000 to that in 2004?
Provide a succinct answer. 1.02. What is the ratio of the Production index(2004-2006) in Uganda in 2000 to that in 2004?
Your answer should be compact. 0.86. What is the ratio of the Production index(2004-2006) in Japan in 2000 to that in 2005?
Give a very brief answer. 1.03. What is the ratio of the Production index(2004-2006) in Jordan in 2000 to that in 2005?
Offer a terse response. 0.83. What is the ratio of the Production index(2004-2006) in Sri Lanka in 2000 to that in 2005?
Ensure brevity in your answer.  0.93. What is the ratio of the Production index(2004-2006) of Uganda in 2000 to that in 2005?
Provide a short and direct response. 0.86. What is the ratio of the Production index(2004-2006) of Japan in 2001 to that in 2002?
Provide a succinct answer. 0.99. What is the ratio of the Production index(2004-2006) of Jordan in 2001 to that in 2002?
Provide a short and direct response. 0.77. What is the ratio of the Production index(2004-2006) in Uganda in 2001 to that in 2002?
Your answer should be compact. 0.96. What is the ratio of the Production index(2004-2006) in Japan in 2001 to that in 2003?
Keep it short and to the point. 1.02. What is the ratio of the Production index(2004-2006) in Jordan in 2001 to that in 2003?
Offer a very short reply. 0.81. What is the ratio of the Production index(2004-2006) of Uganda in 2001 to that in 2003?
Keep it short and to the point. 0.91. What is the ratio of the Production index(2004-2006) of Japan in 2001 to that in 2004?
Keep it short and to the point. 1.02. What is the ratio of the Production index(2004-2006) of Jordan in 2001 to that in 2004?
Provide a succinct answer. 0.72. What is the ratio of the Production index(2004-2006) of Uganda in 2001 to that in 2004?
Your answer should be compact. 0.91. What is the ratio of the Production index(2004-2006) in Jordan in 2001 to that in 2005?
Give a very brief answer. 0.74. What is the ratio of the Production index(2004-2006) in Sri Lanka in 2001 to that in 2005?
Keep it short and to the point. 0.92. What is the ratio of the Production index(2004-2006) of Uganda in 2001 to that in 2005?
Your answer should be very brief. 0.91. What is the ratio of the Production index(2004-2006) of Japan in 2002 to that in 2003?
Ensure brevity in your answer.  1.03. What is the ratio of the Production index(2004-2006) of Jordan in 2002 to that in 2003?
Offer a very short reply. 1.05. What is the ratio of the Production index(2004-2006) of Sri Lanka in 2002 to that in 2003?
Ensure brevity in your answer.  0.96. What is the ratio of the Production index(2004-2006) in Uganda in 2002 to that in 2003?
Offer a very short reply. 0.95. What is the ratio of the Production index(2004-2006) of Japan in 2002 to that in 2004?
Make the answer very short. 1.03. What is the ratio of the Production index(2004-2006) of Jordan in 2002 to that in 2004?
Make the answer very short. 0.93. What is the ratio of the Production index(2004-2006) of Sri Lanka in 2002 to that in 2004?
Ensure brevity in your answer.  1.01. What is the ratio of the Production index(2004-2006) in Uganda in 2002 to that in 2004?
Your answer should be compact. 0.95. What is the ratio of the Production index(2004-2006) in Japan in 2002 to that in 2005?
Your answer should be very brief. 1.02. What is the ratio of the Production index(2004-2006) of Jordan in 2002 to that in 2005?
Provide a succinct answer. 0.95. What is the ratio of the Production index(2004-2006) of Sri Lanka in 2002 to that in 2005?
Your answer should be compact. 0.92. What is the ratio of the Production index(2004-2006) of Uganda in 2002 to that in 2005?
Keep it short and to the point. 0.95. What is the ratio of the Production index(2004-2006) of Japan in 2003 to that in 2004?
Keep it short and to the point. 0.99. What is the ratio of the Production index(2004-2006) in Jordan in 2003 to that in 2004?
Offer a terse response. 0.89. What is the ratio of the Production index(2004-2006) of Sri Lanka in 2003 to that in 2004?
Make the answer very short. 1.05. What is the ratio of the Production index(2004-2006) of Japan in 2003 to that in 2005?
Make the answer very short. 0.98. What is the ratio of the Production index(2004-2006) of Jordan in 2003 to that in 2005?
Offer a terse response. 0.91. What is the ratio of the Production index(2004-2006) of Sri Lanka in 2003 to that in 2005?
Ensure brevity in your answer.  0.96. What is the ratio of the Production index(2004-2006) of Uganda in 2003 to that in 2005?
Your answer should be compact. 1. What is the ratio of the Production index(2004-2006) of Japan in 2004 to that in 2005?
Ensure brevity in your answer.  0.99. What is the ratio of the Production index(2004-2006) of Sri Lanka in 2004 to that in 2005?
Ensure brevity in your answer.  0.91. What is the ratio of the Production index(2004-2006) in Uganda in 2004 to that in 2005?
Your answer should be very brief. 1. What is the difference between the highest and the second highest Production index(2004-2006) in Japan?
Your response must be concise. 0.53. What is the difference between the highest and the second highest Production index(2004-2006) of Jordan?
Provide a succinct answer. 2.53. What is the difference between the highest and the second highest Production index(2004-2006) in Sri Lanka?
Keep it short and to the point. 3.97. What is the difference between the highest and the second highest Production index(2004-2006) of Uganda?
Keep it short and to the point. 0.12. What is the difference between the highest and the lowest Production index(2004-2006) of Japan?
Ensure brevity in your answer.  4.85. What is the difference between the highest and the lowest Production index(2004-2006) in Jordan?
Offer a terse response. 33.24. What is the difference between the highest and the lowest Production index(2004-2006) in Sri Lanka?
Ensure brevity in your answer.  9.09. What is the difference between the highest and the lowest Production index(2004-2006) in Uganda?
Ensure brevity in your answer.  16.85. 